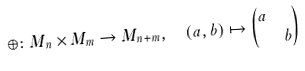<formula> <loc_0><loc_0><loc_500><loc_500>\oplus \colon M _ { n } \times M _ { m } & \to M _ { n + m } , \quad ( a , b ) \mapsto \begin{pmatrix} a & \\ & b \end{pmatrix}</formula> 